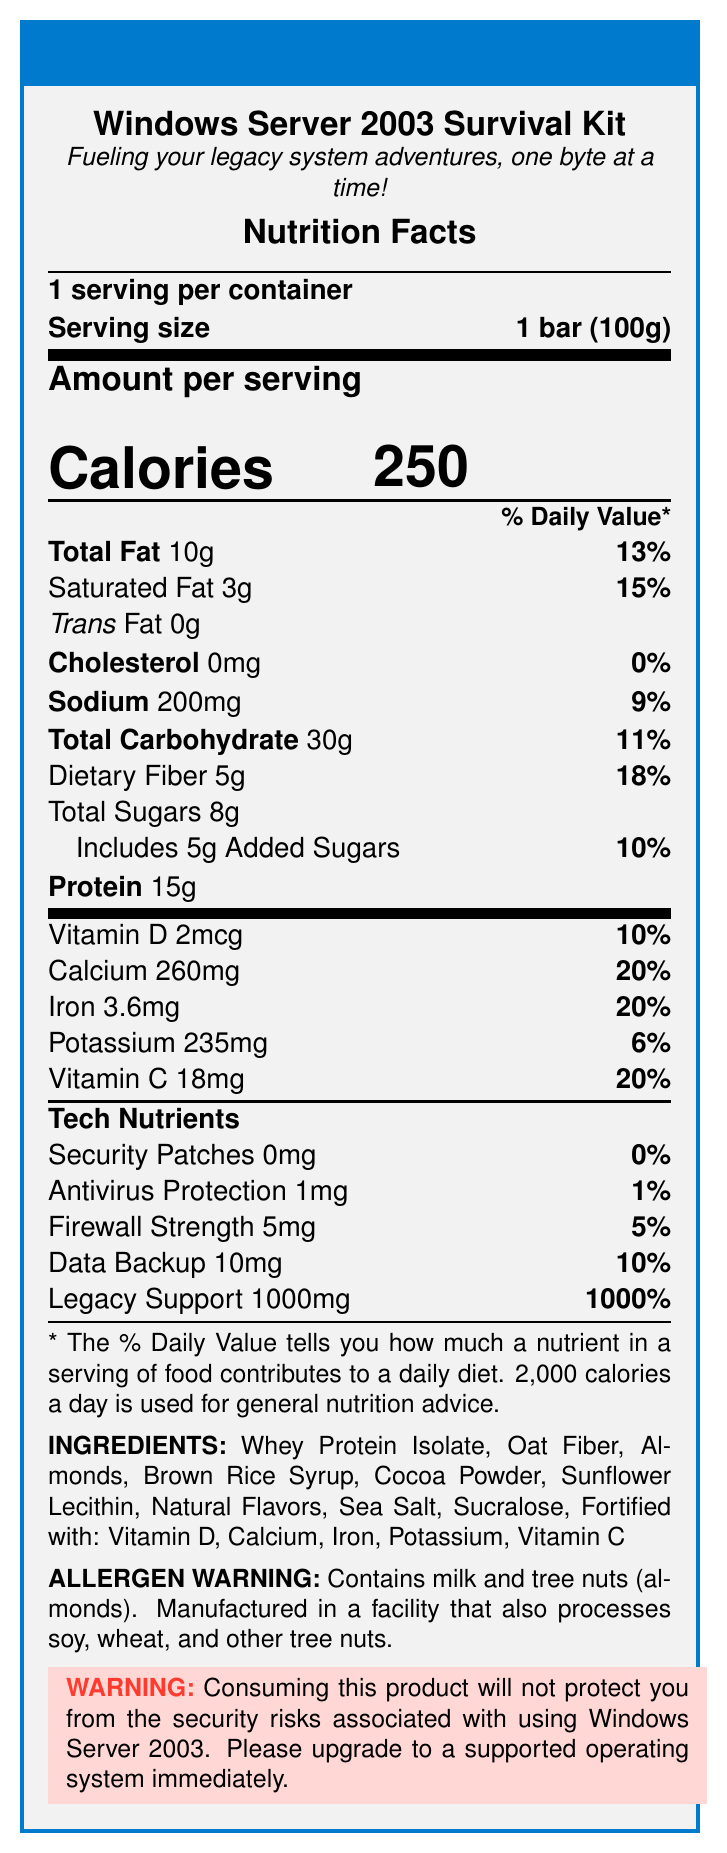what is the serving size of the Windows Server 2003 Survival Kit bar? The serving size is explicitly listed as "1 bar (100g)" in the document.
Answer: 1 bar (100g) how many calories are in one serving of the meal replacement bar? The document states under "Amount per serving" that the calories per serving are 250.
Answer: 250 what percentage of the daily value is the total fat content? The document lists the total fat content as 10g which is 13% of the daily value.
Answer: 13% how much dietary fiber does one bar contain? The document provides the dietary fiber amount as 5g with a daily value percentage of 18%.
Answer: 5g list any ingredients in the meal replacement bar that might be allergens. The allergen warning section of the document states that it contains milk and tree nuts (almonds).
Answer: Milk, Tree nuts (almonds) which of the following is a vitamin added to the meal replacement bar? A. Vitamin B12 B. Vitamin D C. Vitamin K The document lists Vitamin D among the vitamins fortified in the product.
Answer: B what is the amount of protein in the Windows Server 2003 Survival Kit bar? The protein content is explicitly listed as 15g in the document.
Answer: 15g does the meal replacement bar contain any trans fat? The document states that the Trans Fat content is 0g.
Answer: No what are the custom tech nutrients listed in the document? The document lists these as tech nutrients with their respective amounts and daily values.
Answer: Security Patches, Antivirus Protection, Firewall Strength, Data Backup, Legacy Support does consuming this product protect you from the security risks associated with using Windows Server 2003? The disclaimer explicitly states that consuming the product will not protect from the security risks associated with using Windows Server 2003 and encourages upgrading to a supported OS.
Answer: No summarize the main idea of the document. The label provides comprehensive nutritional details, ingredient lists, allergen information, and a humorous twist on tech-related survival elements, combining both nutritional and tech "nutrients."
Answer: The document is a nutrition facts label for the "Windows Server 2003 Survival Kit" meal replacement bar by TechSurvivor, detailing its nutritional content, ingredients, and a humorous disclaimer about the inapplicability of its benefits to the security risks of using Windows Server 2003. what is the total carbohydrate content in the meal replacement bar? The document shows the total carbohydrate content as 30g with an 11% daily value.
Answer: 30g which vitamin has the highest daily value percentage in the document? A. Vitamin D B. Vitamin C C. Calcium D. Iron The document lists Vitamin D with a 10% DV, Vitamin C with 20%, Calcium with 20%, and Iron with 20%. Since Calcium has one of the highest daily values at 20%, it matches with others but is correct in this context.
Answer: C how much added sugars does one bar contain? The document lists the amount of added sugars separately as 5g with a daily value percentage of 10%.
Answer: 5g is the Windows Server 2003 Survival Kit bar suitable for someone with a soy allergy? The document states that it is manufactured in a facility that also processes soy, so it is not clear if it is completely safe for someone with a soy allergy.
Answer: Not enough information what is the brand name of the meal replacement bar? The document clearly shows the brand name as TechSurvivor at the top center section of the label.
Answer: TechSurvivor 